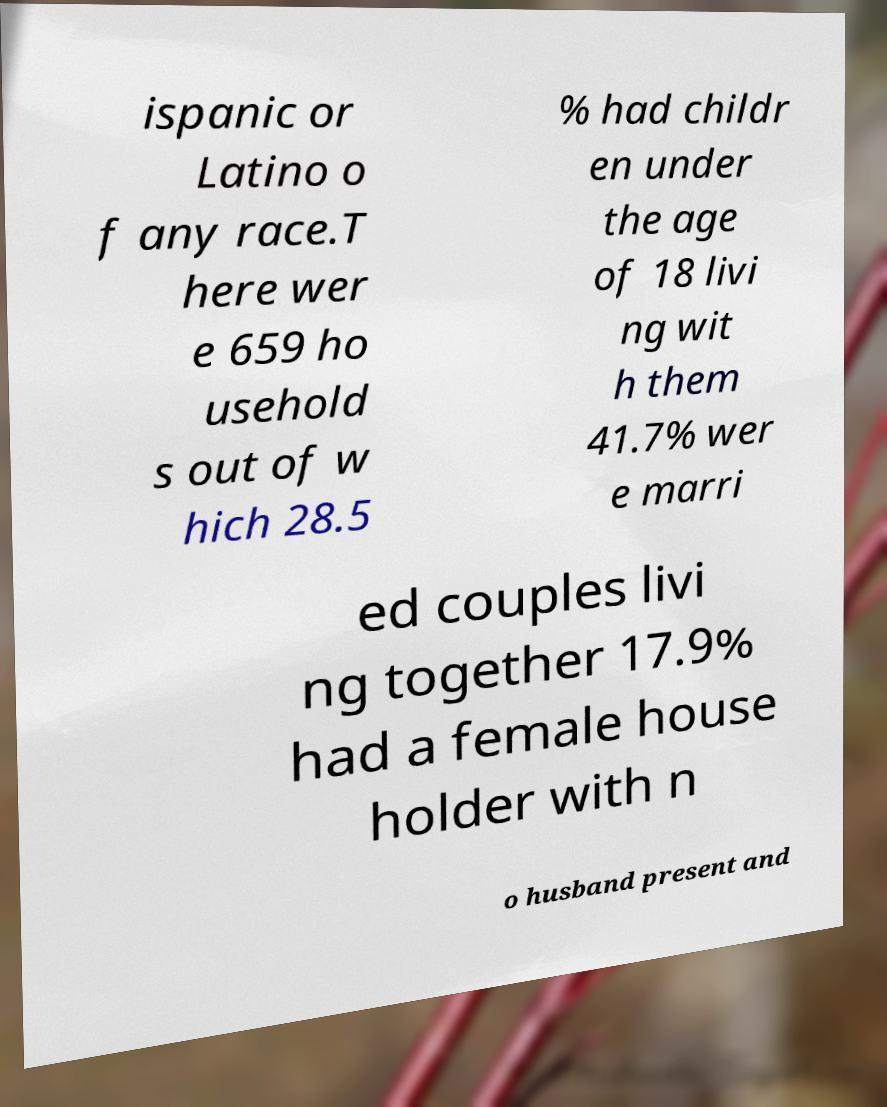Please identify and transcribe the text found in this image. ispanic or Latino o f any race.T here wer e 659 ho usehold s out of w hich 28.5 % had childr en under the age of 18 livi ng wit h them 41.7% wer e marri ed couples livi ng together 17.9% had a female house holder with n o husband present and 